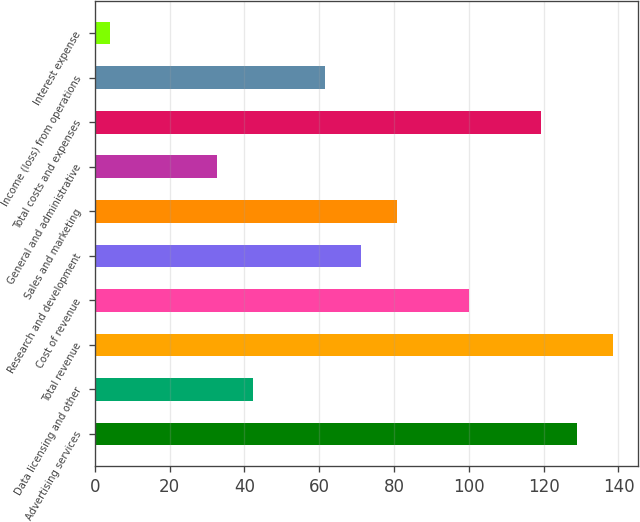Convert chart to OTSL. <chart><loc_0><loc_0><loc_500><loc_500><bar_chart><fcel>Advertising services<fcel>Data licensing and other<fcel>Total revenue<fcel>Cost of revenue<fcel>Research and development<fcel>Sales and marketing<fcel>General and administrative<fcel>Total costs and expenses<fcel>Income (loss) from operations<fcel>Interest expense<nl><fcel>128.8<fcel>42.4<fcel>138.4<fcel>100<fcel>71.2<fcel>80.8<fcel>32.8<fcel>119.2<fcel>61.6<fcel>4<nl></chart> 